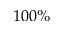<formula> <loc_0><loc_0><loc_500><loc_500>1 0 0 \%</formula> 